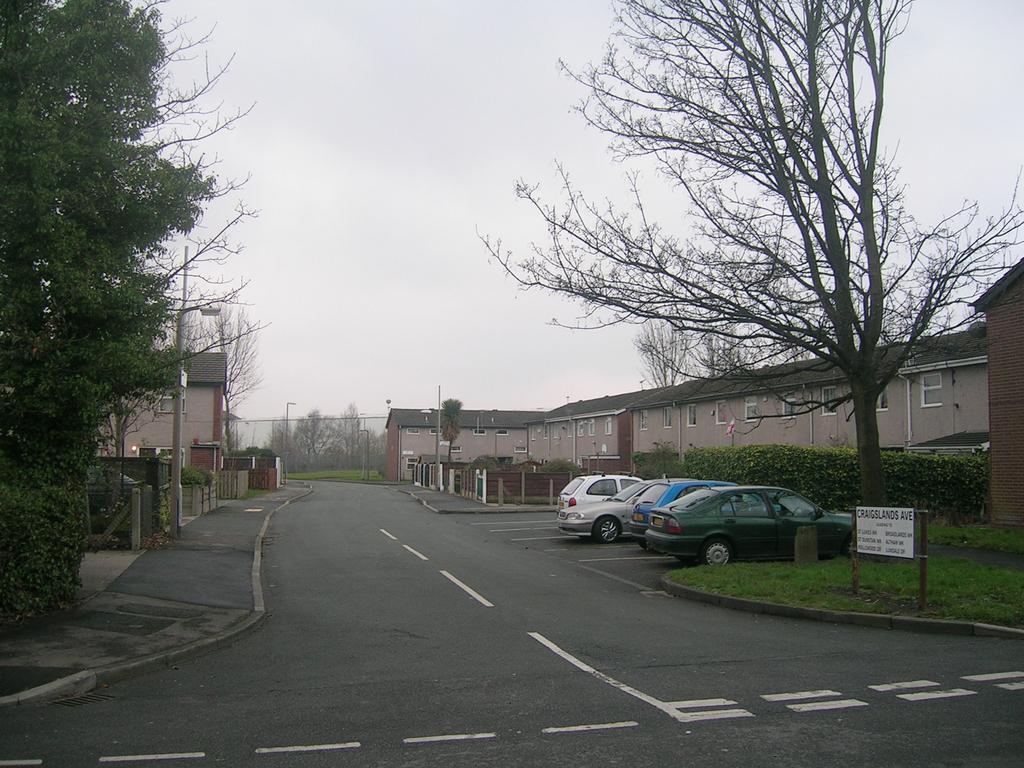In one or two sentences, can you explain what this image depicts? In this picture we can see cars on the road, footpaths, poles, name board, buildings with windows, grass, trees, fences and in the background we can see the sky. 